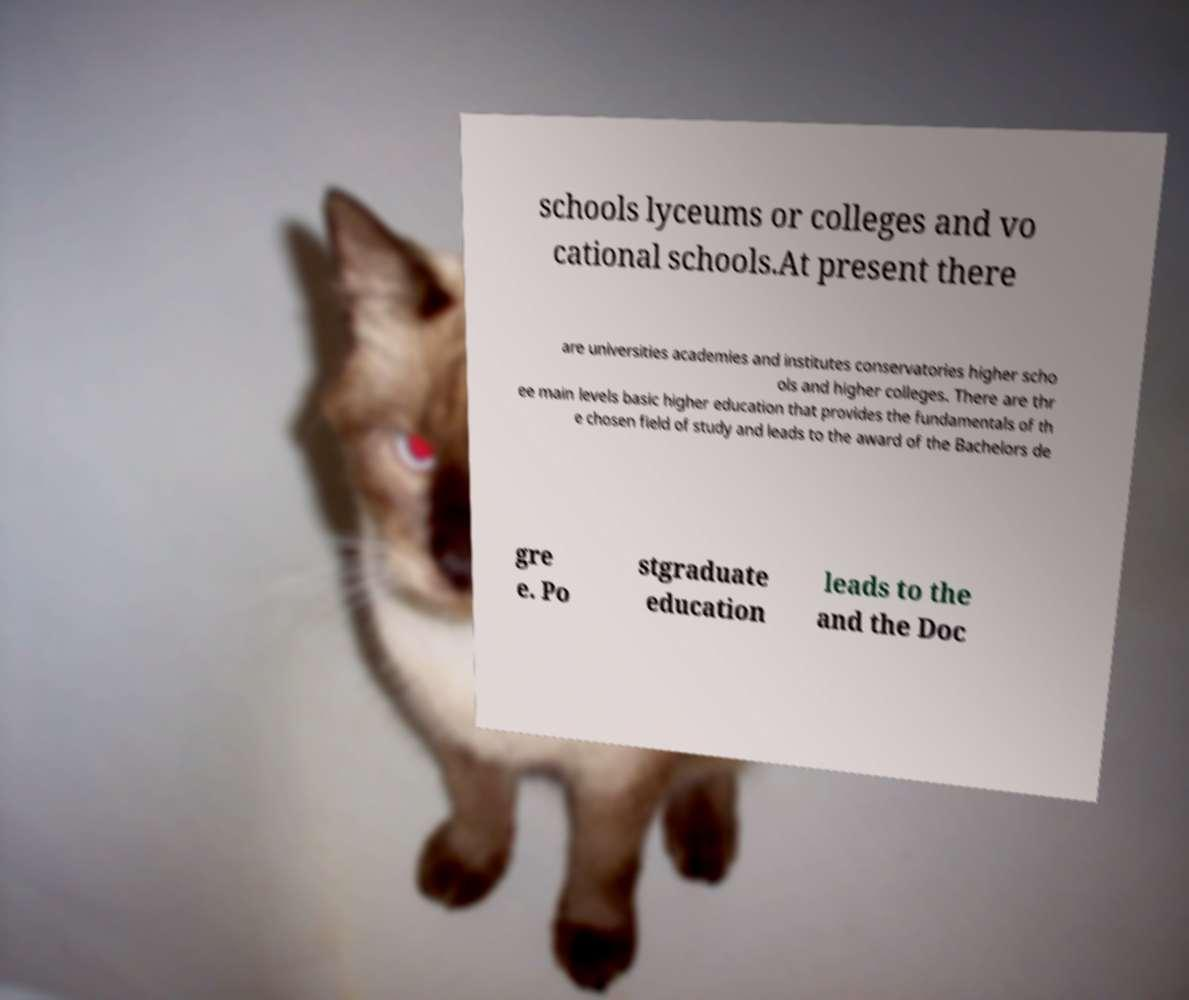Can you read and provide the text displayed in the image?This photo seems to have some interesting text. Can you extract and type it out for me? schools lyceums or colleges and vo cational schools.At present there are universities academies and institutes conservatories higher scho ols and higher colleges. There are thr ee main levels basic higher education that provides the fundamentals of th e chosen field of study and leads to the award of the Bachelors de gre e. Po stgraduate education leads to the and the Doc 